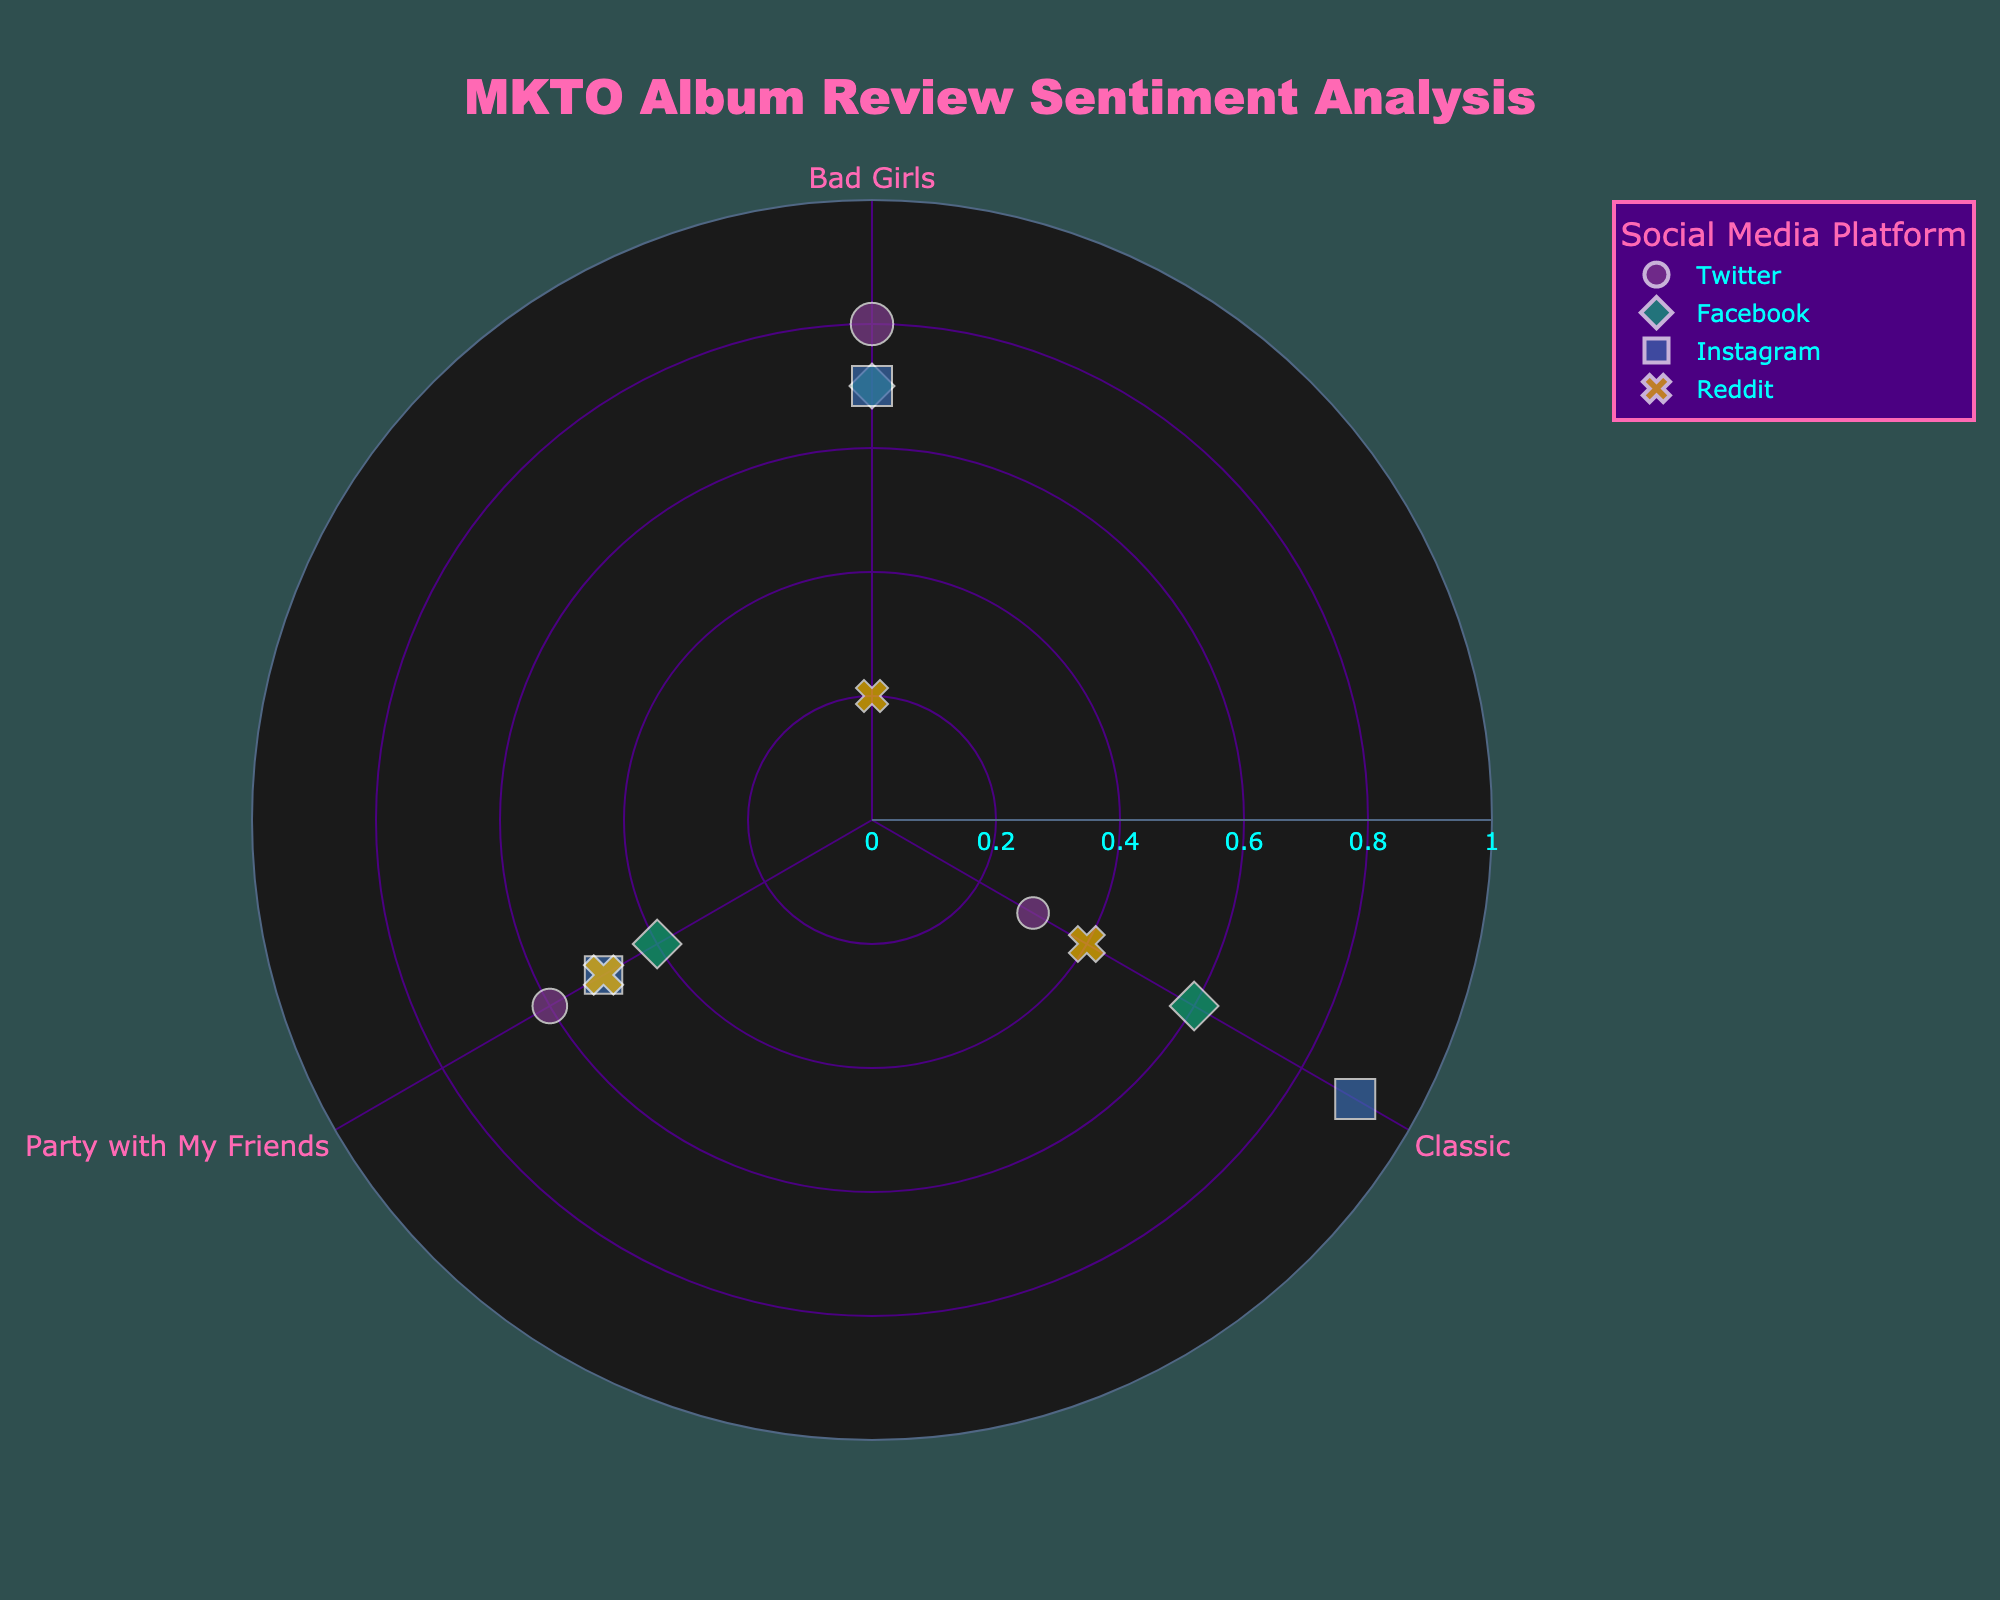What is the title of the figure? The title of the figure is prominently displayed at the top and usually gives a concise description of the chart. In this case, the title is centered at the top in a bright color.
Answer: MKTO Album Review Sentiment Analysis Which social media platform has the highest review sentiment for the album "Classic"? By looking at the data points for the album "Classic," you can compare the review sentiments for each platform. The highest value is marked by Instagram.
Answer: Instagram How many data points in total are shown on the chart? You can count the total number of data points by summing the instances of each album review sentiment across all platforms. There are 12 points in total.
Answer: 12 Which album has the widest range of review sentiments? By examining the radial positions (review sentiments) of the points for each album, you can determine which one has the most variation from low to high sentiment. "Classic" shows the widest range, from 0.3 to 0.9.
Answer: Classic Which platform has the most uniform emotion intensity for "Party with My Friends"? Emotion intensity is indicated by the size of the points. For all platforms reviewing "Party with My Friends," Twitter and Reddit have the most uniform and smallest size range.
Answer: Twitter Which data point has the lowest review sentiment and what are its album and platform? By finding the point closest to the center, you can identify the lowest sentiment. The lowest value is 0.2 for "Bad Girls" on Reddit.
Answer: Bad Girls on Reddit Compare the average emotion intensity of reviews for "Classic" on Twitter and Instagram. First, isolate the emotion intensities for "Classic" on Twitter (0.5) and Instagram (0.8). Then calculate the average: (0.5 + 0.8)/2 = 0.65.
Answer: 0.65 What platforms reviewed the album "Bad Girls" and what are the review sentiments? By checking the points corresponding to "Bad Girls," you can list the platforms and their sentiments. They are Twitter (0.8), Instagram (0.7), Facebook (0.7), and Reddit (0.2).
Answer: Twitter (0.8), Instagram (0.7), Facebook (0.7), Reddit (0.2) Which album received the most consistently positive reviews across all platforms? Consistency in positive reviews means a higher and closely range sentiment for all platforms. "Classic" has high values (0.6, 0.9, 0.4, 0.4) except one lower value.
Answer: Classic Based on the chart, which social media platform generally has the most intense emotions in reviews? The general size of the markers indicates emotion intensity. By comparing all platforms across different albums, Instagram and Facebook have larger average marker sizes.
Answer: Instagram and Facebook 